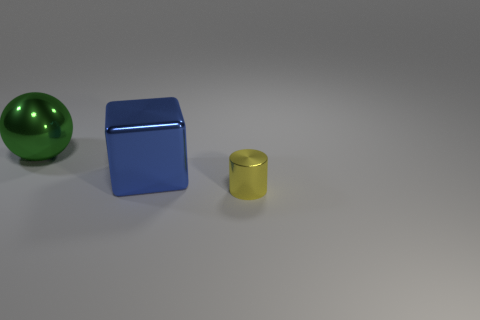There is a object that is behind the big metallic thing that is on the right side of the big green object; what size is it?
Your answer should be compact. Large. There is a thing that is on the left side of the large shiny block; what material is it?
Offer a very short reply. Metal. How many objects are metallic objects behind the tiny thing or metal objects behind the tiny yellow cylinder?
Your response must be concise. 2. There is a big shiny thing in front of the big green metallic thing; is its color the same as the metallic object that is to the left of the blue metallic object?
Your answer should be very brief. No. Is there a yellow metallic thing of the same size as the cylinder?
Keep it short and to the point. No. The object that is to the right of the large shiny sphere and to the left of the small yellow cylinder is made of what material?
Make the answer very short. Metal. What number of metal things are either big blue cubes or green cylinders?
Your answer should be compact. 1. What is the shape of the yellow thing that is the same material as the blue object?
Keep it short and to the point. Cylinder. What number of things are both behind the blue shiny cube and on the right side of the blue metallic thing?
Make the answer very short. 0. Is there anything else that is the same shape as the tiny yellow shiny thing?
Keep it short and to the point. No. 